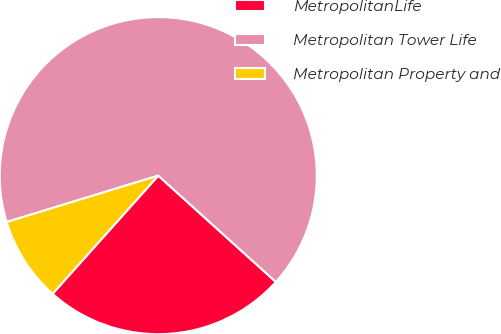Convert chart. <chart><loc_0><loc_0><loc_500><loc_500><pie_chart><fcel>MetropolitanLife<fcel>Metropolitan Tower Life<fcel>Metropolitan Property and<nl><fcel>24.92%<fcel>66.42%<fcel>8.66%<nl></chart> 